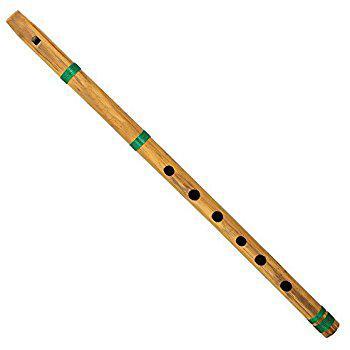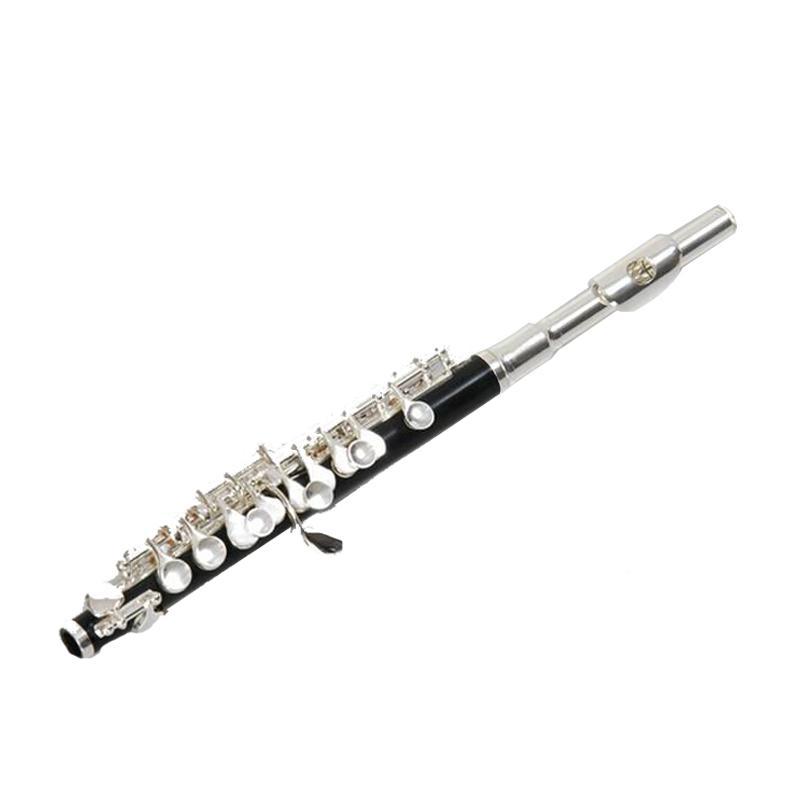The first image is the image on the left, the second image is the image on the right. For the images shown, is this caption "One of the instruments is taken apart into two separate pieces." true? Answer yes or no. No. The first image is the image on the left, the second image is the image on the right. Given the left and right images, does the statement "The left image shows two overlapping, criss-crossed flute parts, and the right image shows at least one flute displayed diagonally." hold true? Answer yes or no. No. 